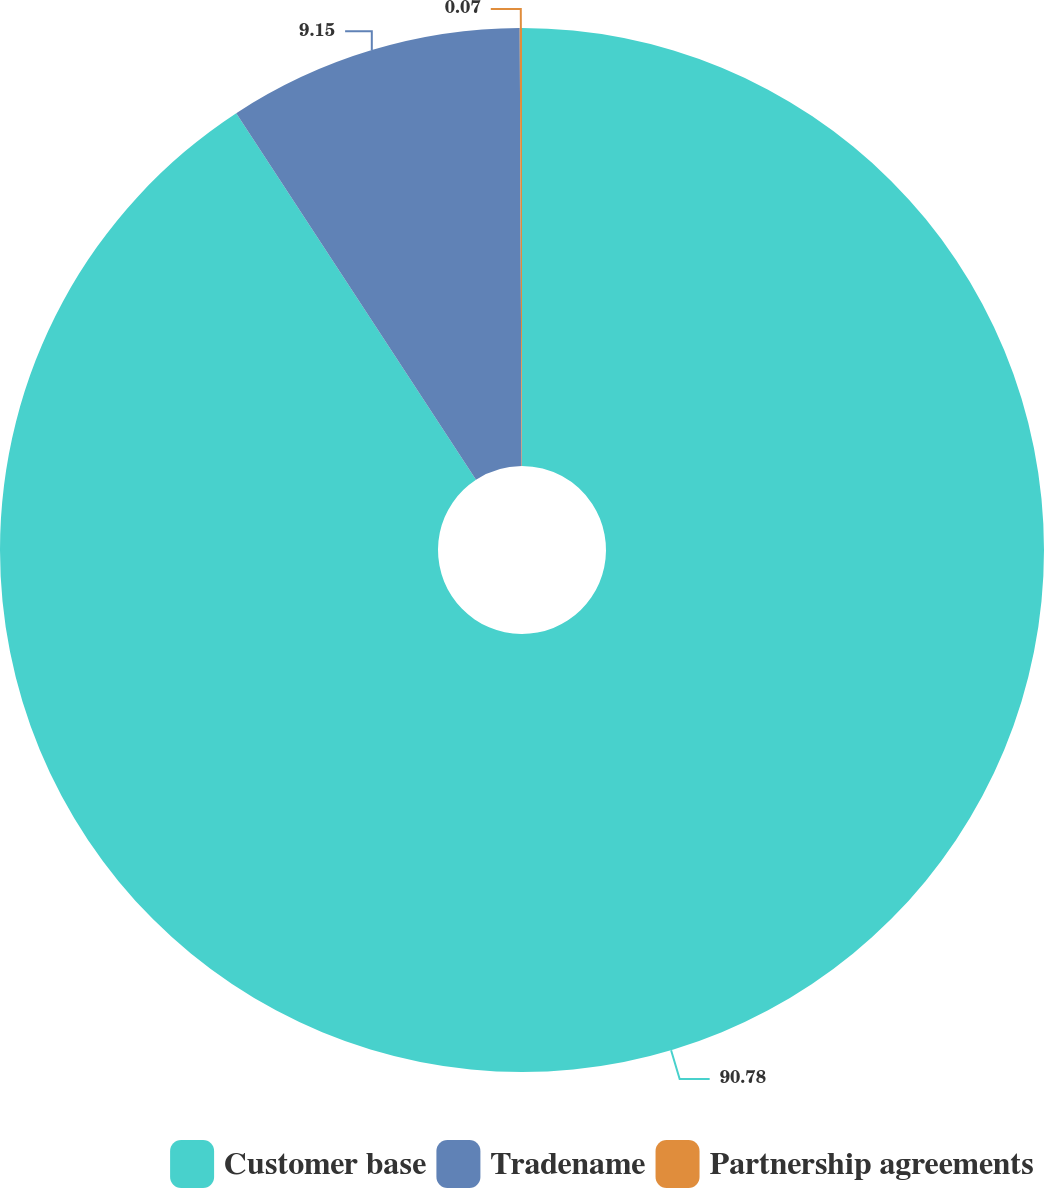Convert chart to OTSL. <chart><loc_0><loc_0><loc_500><loc_500><pie_chart><fcel>Customer base<fcel>Tradename<fcel>Partnership agreements<nl><fcel>90.78%<fcel>9.15%<fcel>0.07%<nl></chart> 